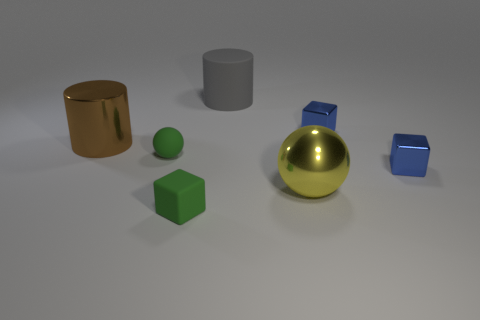Subtract 1 cubes. How many cubes are left? 2 Add 1 green blocks. How many objects exist? 8 Subtract all balls. How many objects are left? 5 Add 1 big matte cylinders. How many big matte cylinders exist? 2 Subtract 0 purple cylinders. How many objects are left? 7 Subtract all metal objects. Subtract all large cylinders. How many objects are left? 1 Add 3 small green cubes. How many small green cubes are left? 4 